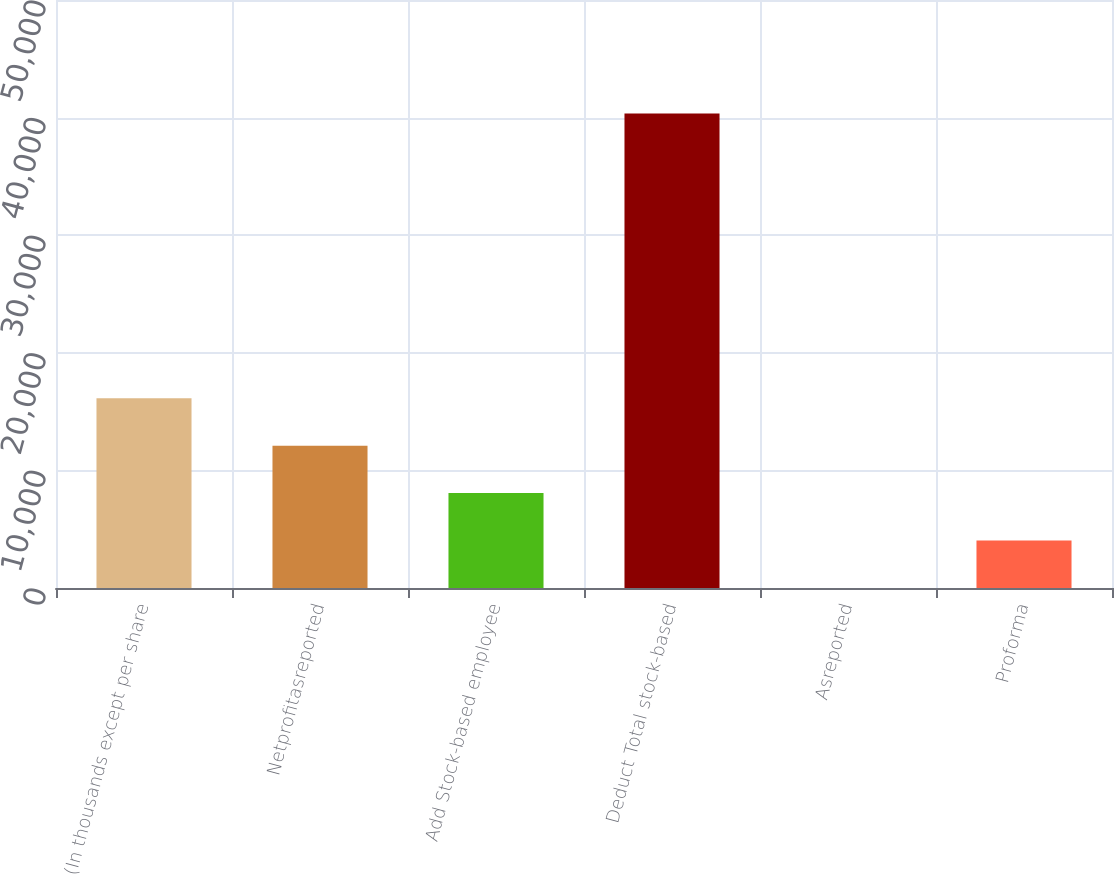<chart> <loc_0><loc_0><loc_500><loc_500><bar_chart><fcel>(In thousands except per share<fcel>Netprofitasreported<fcel>Add Stock-based employee<fcel>Deduct Total stock-based<fcel>Asreported<fcel>Proforma<nl><fcel>16136.8<fcel>12102.6<fcel>8068.42<fcel>40342<fcel>0.02<fcel>4034.22<nl></chart> 